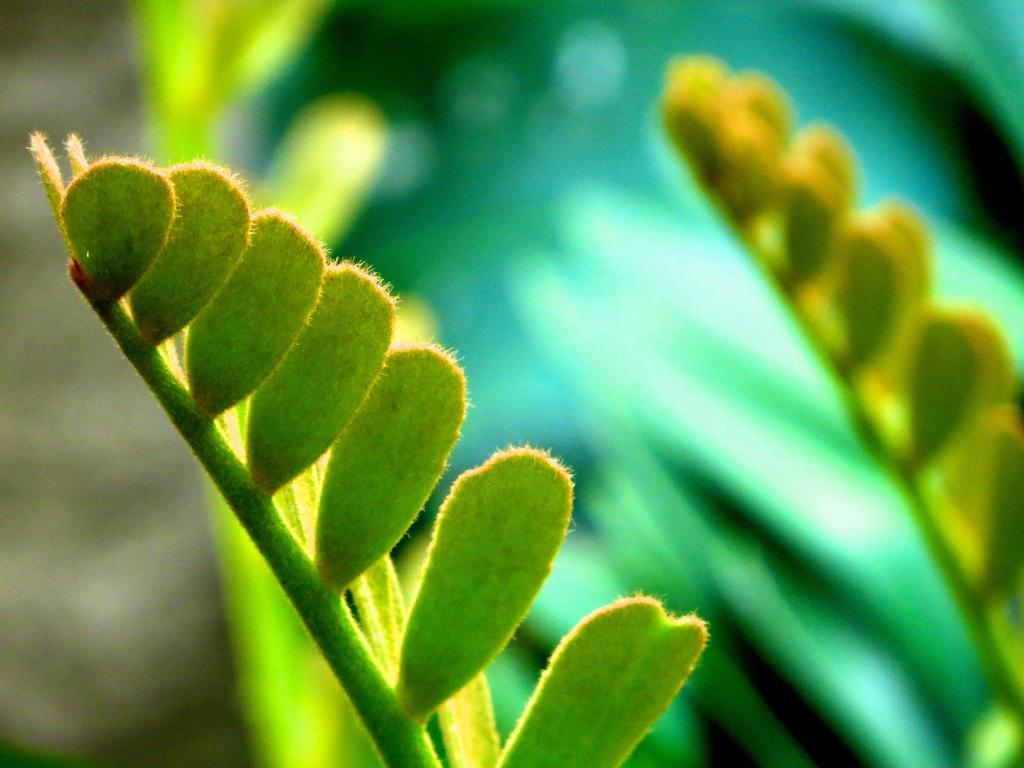Where was the image taken? The image was taken outdoors. Can you describe the background of the image? The background of the image is slightly blurred. What is the main subject in the image? There is a plant in the middle of the image. What color are the leaves of the plant? The leaves of the plant are green. What type of addition problem is being solved in the image? There is no addition problem present in the image; it features a plant with green leaves. What is being served for breakfast in the image? There is no breakfast being served in the image; it is a picture of a plant with green leaves. 